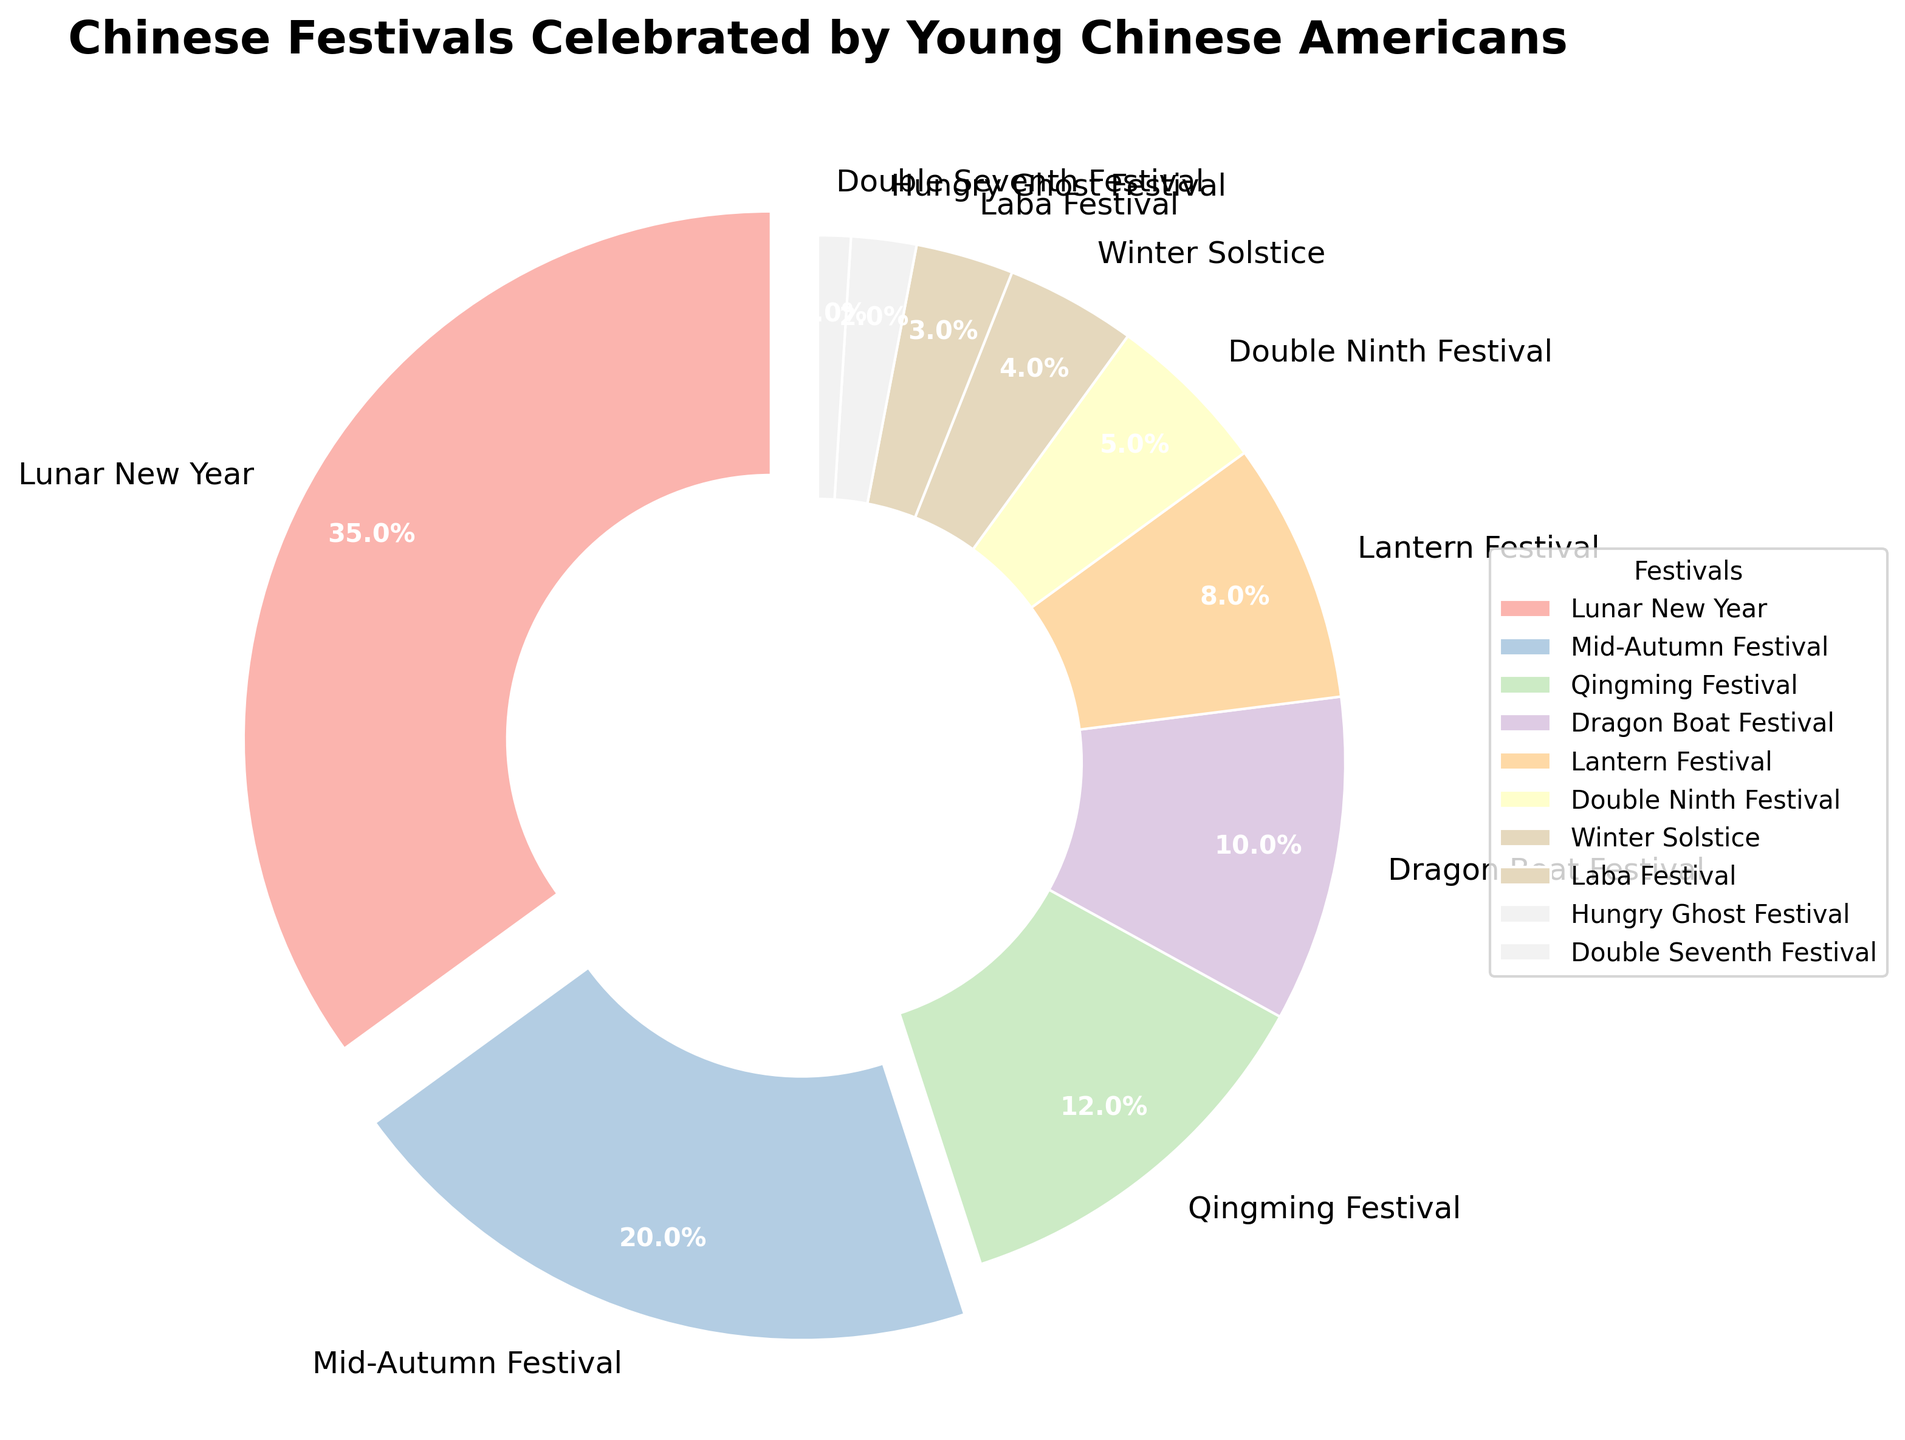Which festival is celebrated the most by young Chinese Americans? Looking at the pie chart, the largest slice represents Lunar New Year.
Answer: Lunar New Year What percentage of young Chinese Americans celebrate the Lantern Festival? By referring to the pie chart, locate the slice labeled "Lantern Festival" to see the percentage.
Answer: 8% Which festival is less celebrated: Qingming Festival or Dragon Boat Festival? Compare the slices for Qingming Festival and Dragon Boat Festival, where Qingming Festival has a bigger slice.
Answer: Dragon Boat Festival How much larger is the percentage of young Chinese Americans celebrating the Mid-Autumn Festival compared to the Hungry Ghost Festival? Subtract the percentage for the Hungry Ghost Festival from the percentage for the Mid-Autumn Festival (20 - 2).
Answer: 18% Which festivals have a percentage greater than 10%? Identify the slices with percentages greater than 10%: Lunar New Year, Mid-Autumn Festival, and Qingming Festival.
Answer: Lunar New Year, Mid-Autumn Festival, Qingming Festival What is the total percentage of young Chinese Americans celebrating the Double Ninth Festival and Winter Solstice together? Add the percentages of both festivals (5 + 4).
Answer: 9% What visual attribute helps highlight the most celebrated festival in the pie chart? The biggest slice, which is slightly pulled out from the center (exploded), along with the largest percentage label.
Answer: Expanding (exploded) slice How many festivals have a celebration percentage of 5% or less? Count the slices with percentages 5% or less: Double Ninth Festival, Winter Solstice, Laba Festival, Hungry Ghost Festival, Double Seventh Festival.
Answer: 5 What is the sum of the percentages for the two least celebrated festivals? Add the percentages of the Hungry Ghost Festival and the Double Seventh Festival (2 + 1).
Answer: 3% Is the percentage of young Chinese Americans celebrating the Dragon Boat Festival closer to the percentage for the Lantern Festival or Mid-Autumn Festival? Compare the absolute differences: Dragon Boat Festival to Lantern Festival (10 - 8 = 2) and Dragon Boat Festival to Mid-Autumn Festival (20 - 10 = 10), determining the shorter difference.
Answer: Lantern Festival 